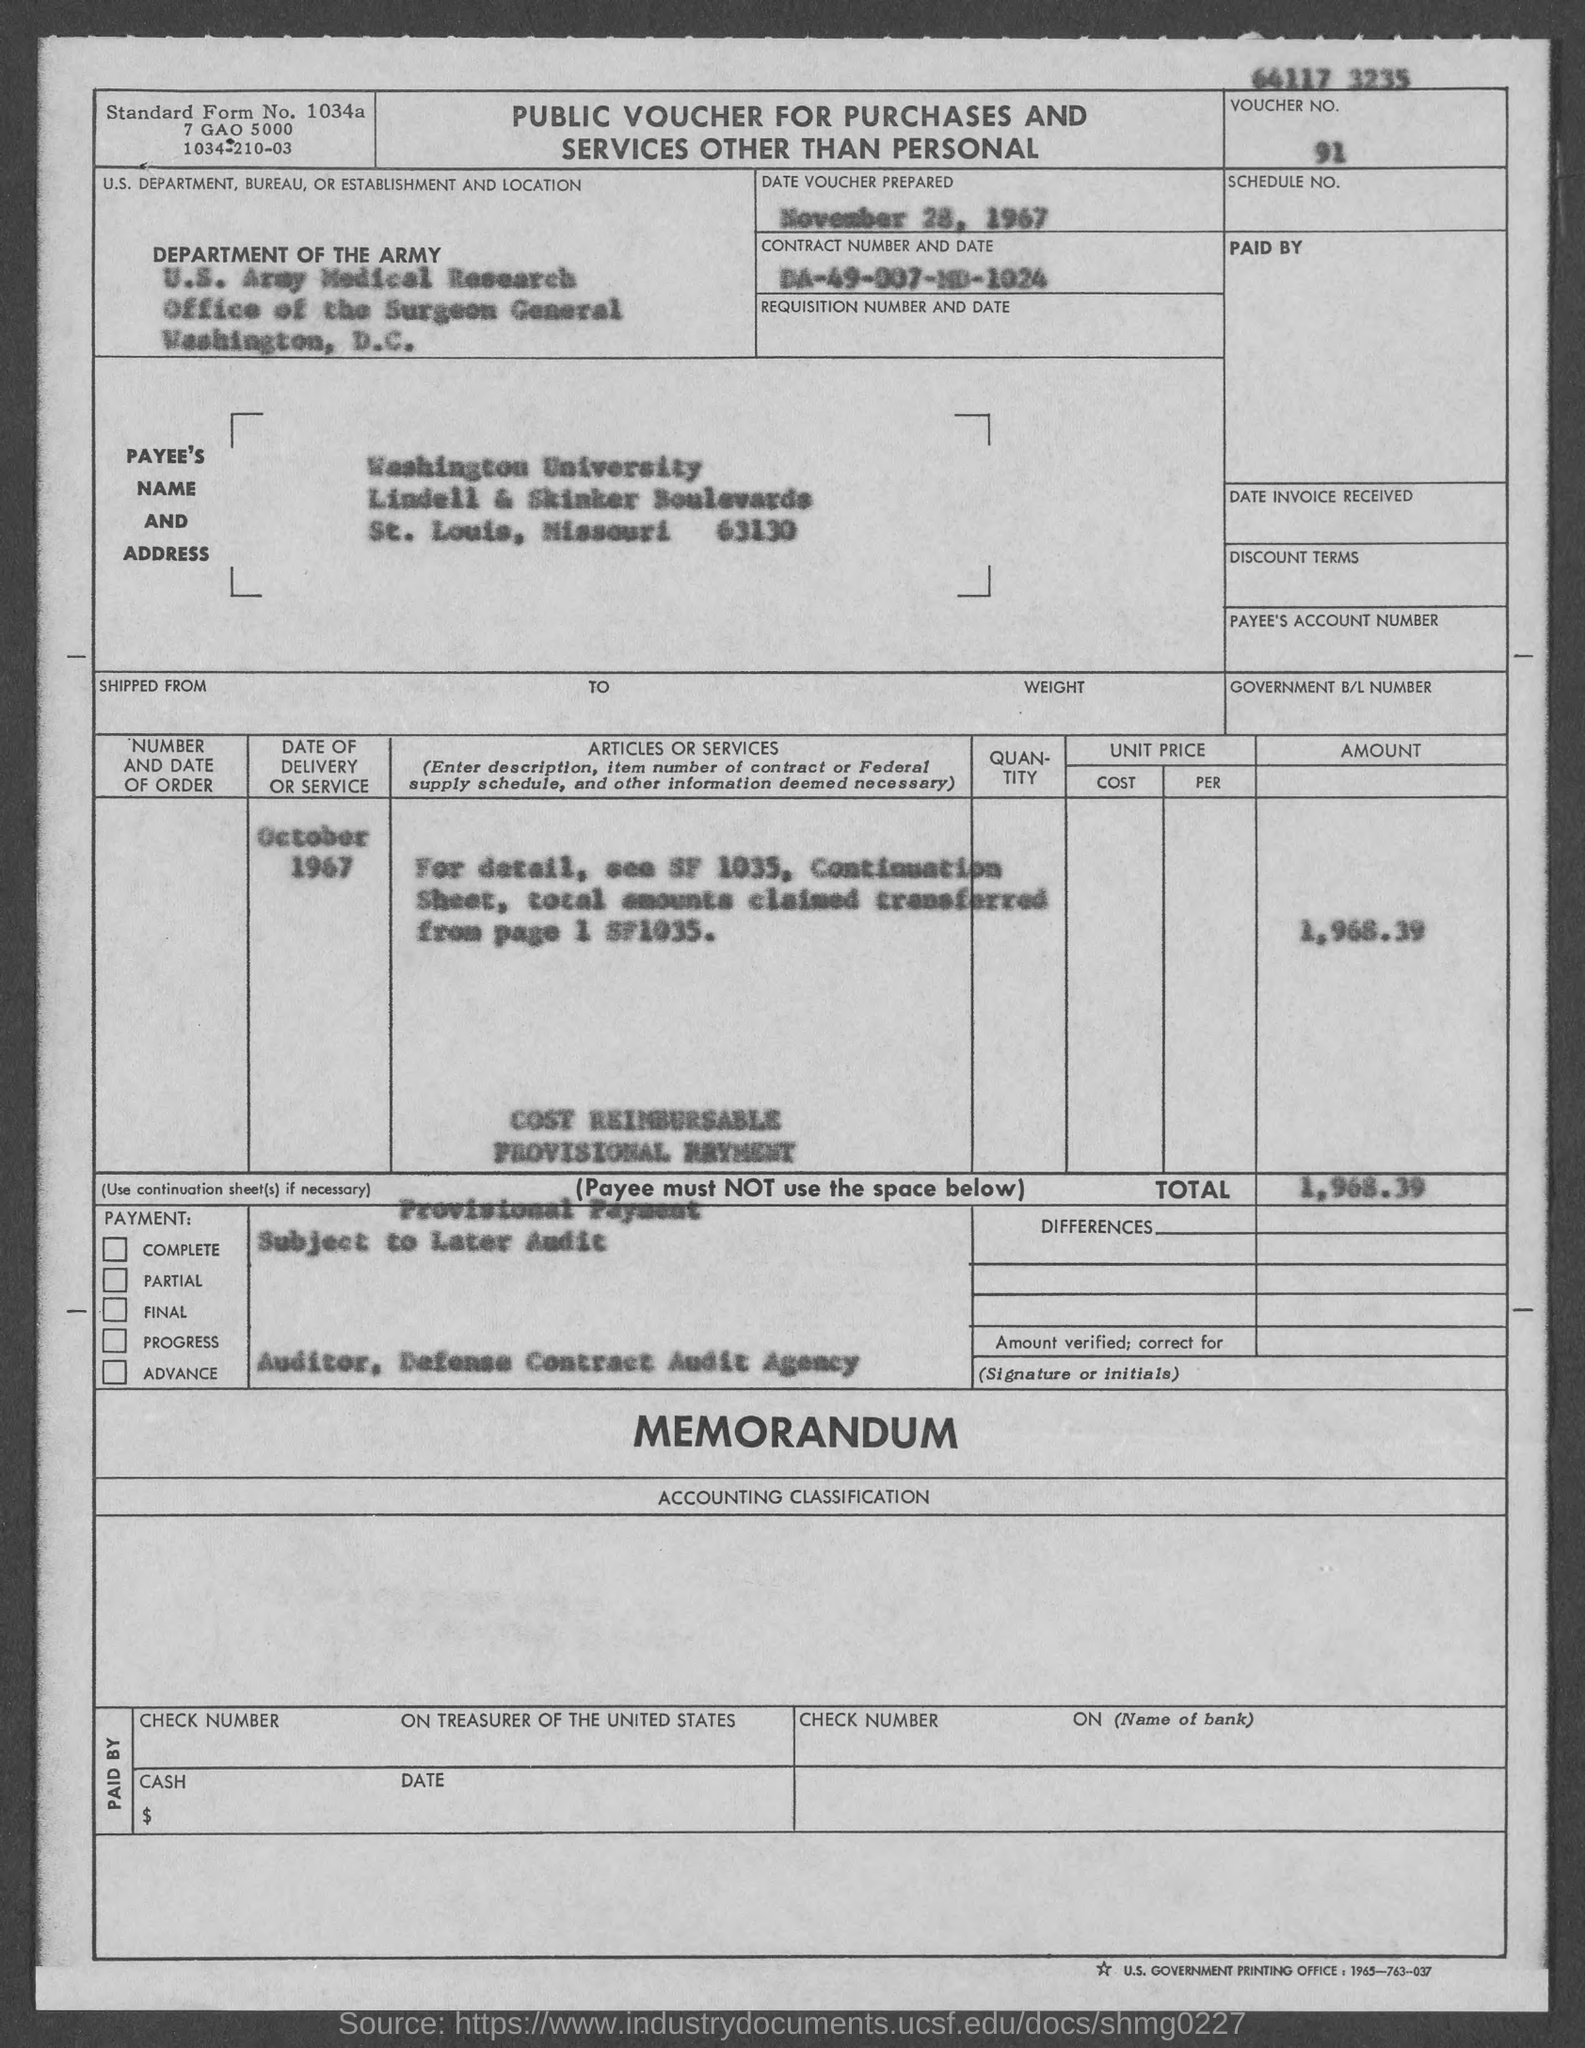What is voucher no.?
Your answer should be very brief. 91. What is contract number ?
Provide a succinct answer. DA-49-007-MD-1024. What is the standard form no.?
Keep it short and to the point. 1034a. On what date is voucher prepared ?
Make the answer very short. November 28, 1967. What is the total ?
Keep it short and to the point. 1,968 39. In which city is office of the surgeon general at ?
Your answer should be very brief. Washington. 